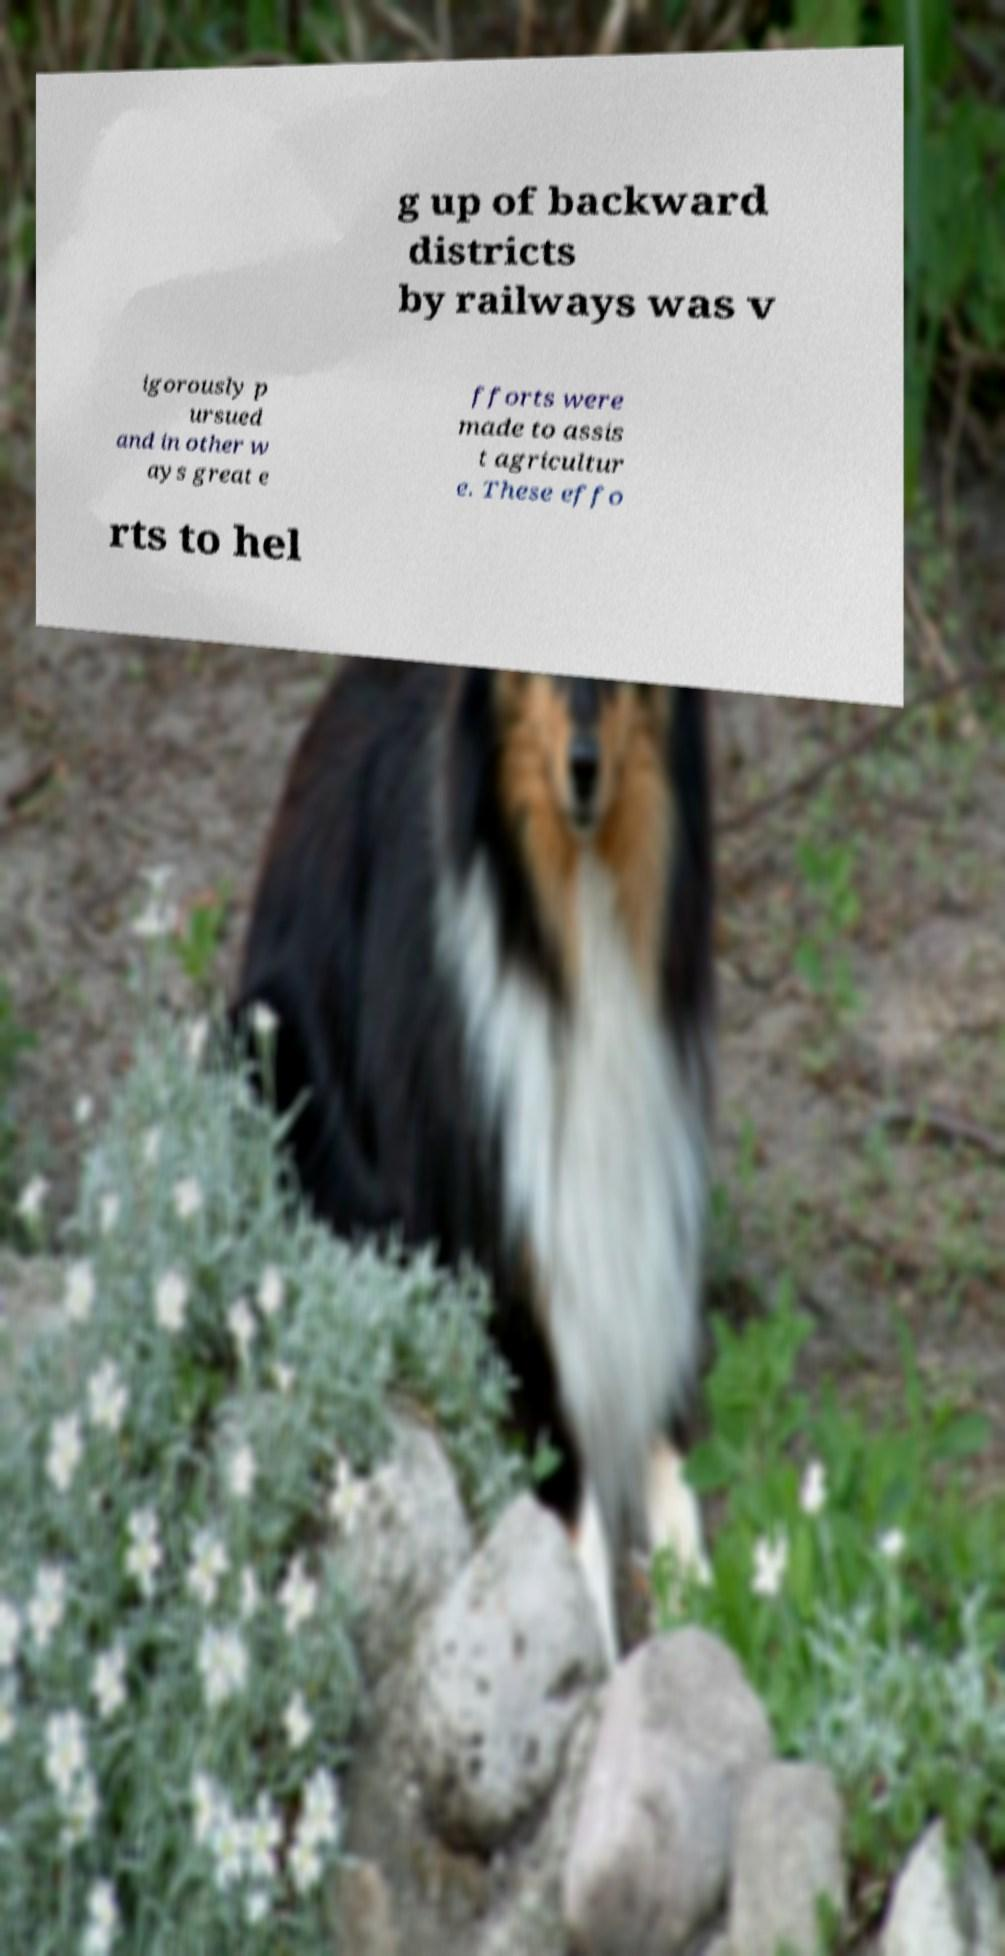Please read and relay the text visible in this image. What does it say? g up of backward districts by railways was v igorously p ursued and in other w ays great e fforts were made to assis t agricultur e. These effo rts to hel 